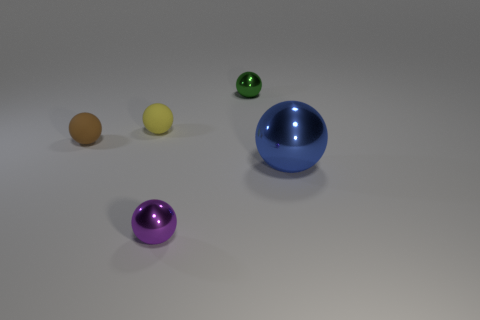How many purple objects are balls or big cylinders?
Your response must be concise. 1. Does the thing that is on the right side of the tiny green shiny object have the same material as the yellow sphere?
Your answer should be very brief. No. What number of things are either large brown cubes or matte balls that are to the right of the brown object?
Your answer should be very brief. 1. How many things are in front of the small metallic sphere that is on the right side of the small metallic ball that is in front of the big blue metallic sphere?
Keep it short and to the point. 4. There is a tiny metallic object that is behind the yellow matte sphere; is its shape the same as the yellow thing?
Keep it short and to the point. Yes. Are there any green metallic balls on the right side of the small metallic sphere that is behind the small brown thing?
Provide a short and direct response. No. How many small cyan rubber cylinders are there?
Offer a very short reply. 0. The ball that is both in front of the brown sphere and left of the blue shiny ball is what color?
Provide a succinct answer. Purple. What size is the other rubber object that is the same shape as the brown object?
Ensure brevity in your answer.  Small. How many yellow balls have the same size as the purple ball?
Make the answer very short. 1. 